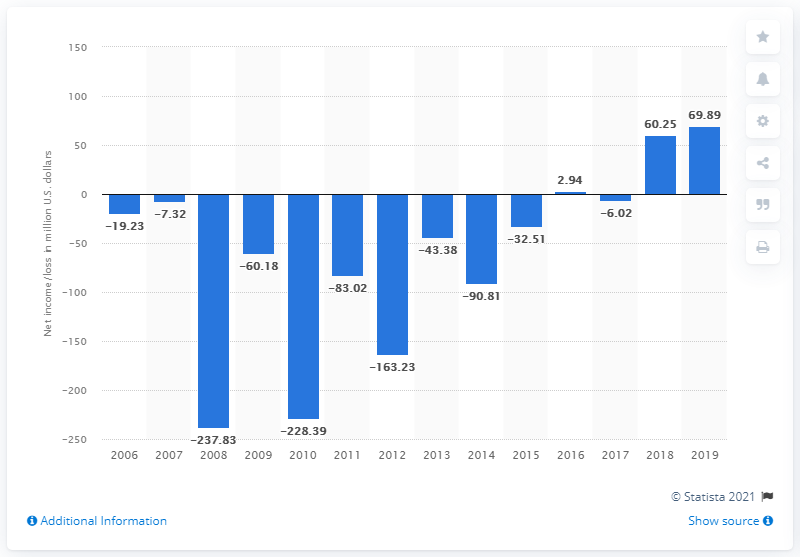Specify some key components in this picture. Live Nation Entertainment's net income increased by 69.89% from the previous year. In 2019, Live Nation Entertainment's net income in dollars was $69.89 million. 